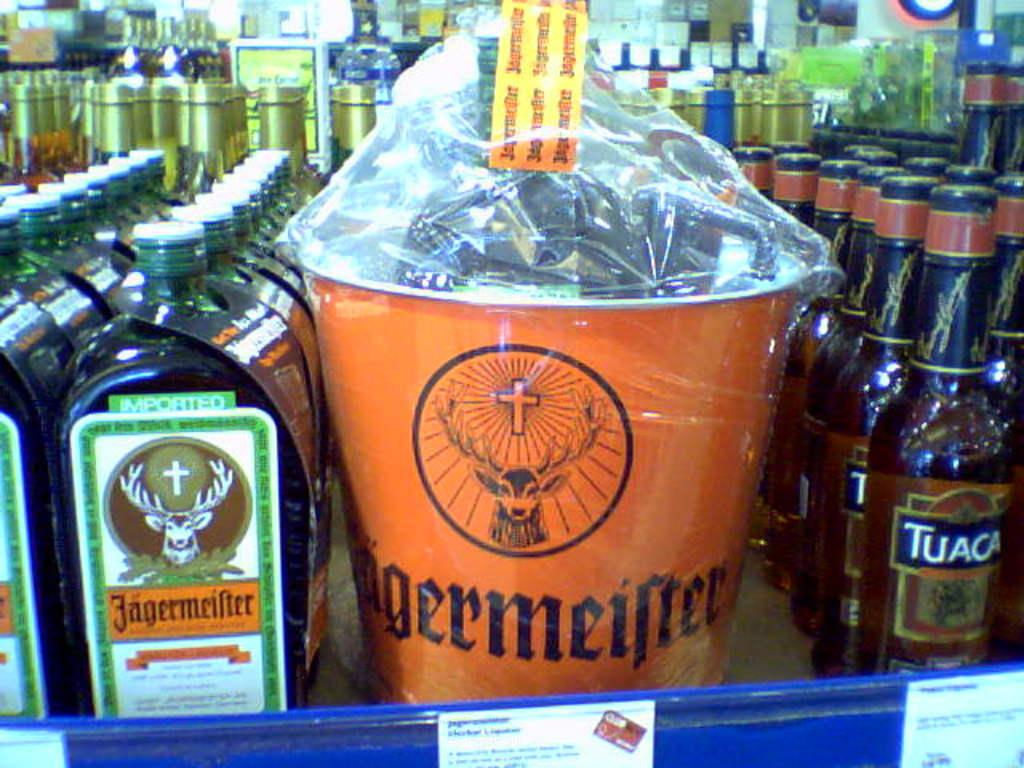<image>
Render a clear and concise summary of the photo. Bottles of Tuaca next to a large orange bucket and some more bottles 